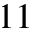Convert formula to latex. <formula><loc_0><loc_0><loc_500><loc_500>1 1</formula> 